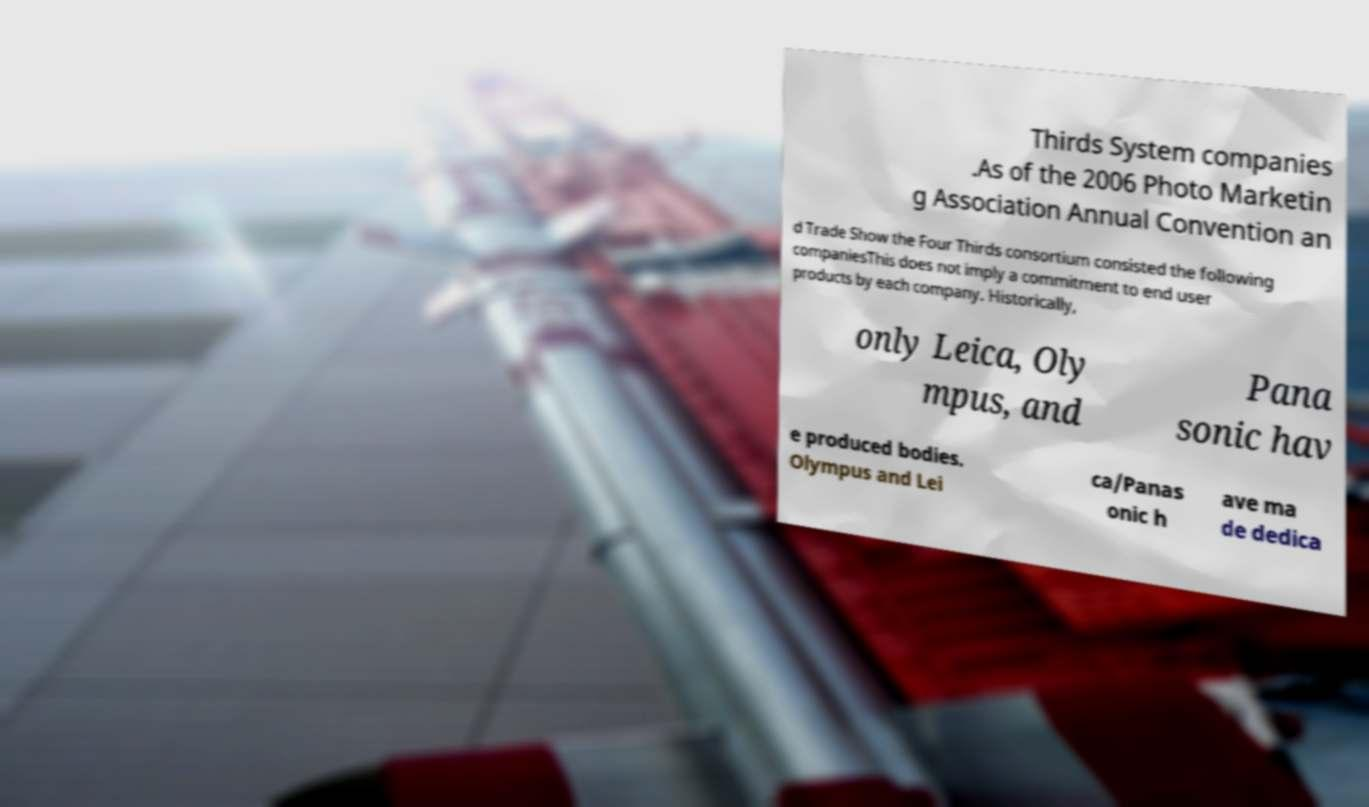Can you accurately transcribe the text from the provided image for me? Thirds System companies .As of the 2006 Photo Marketin g Association Annual Convention an d Trade Show the Four Thirds consortium consisted the following companiesThis does not imply a commitment to end user products by each company. Historically, only Leica, Oly mpus, and Pana sonic hav e produced bodies. Olympus and Lei ca/Panas onic h ave ma de dedica 